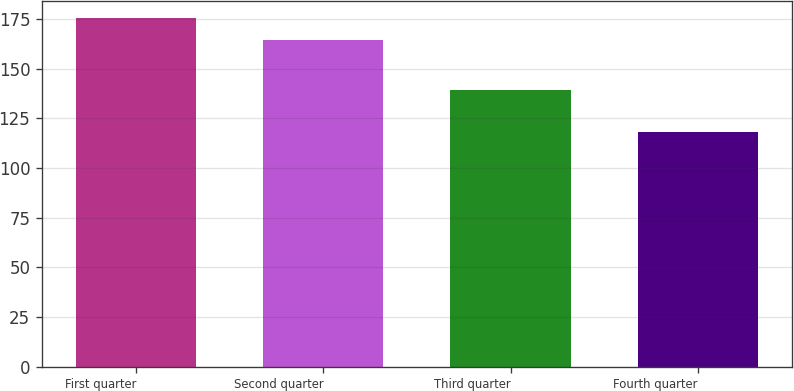Convert chart. <chart><loc_0><loc_0><loc_500><loc_500><bar_chart><fcel>First quarter<fcel>Second quarter<fcel>Third quarter<fcel>Fourth quarter<nl><fcel>175.34<fcel>164.4<fcel>139.25<fcel>118.07<nl></chart> 